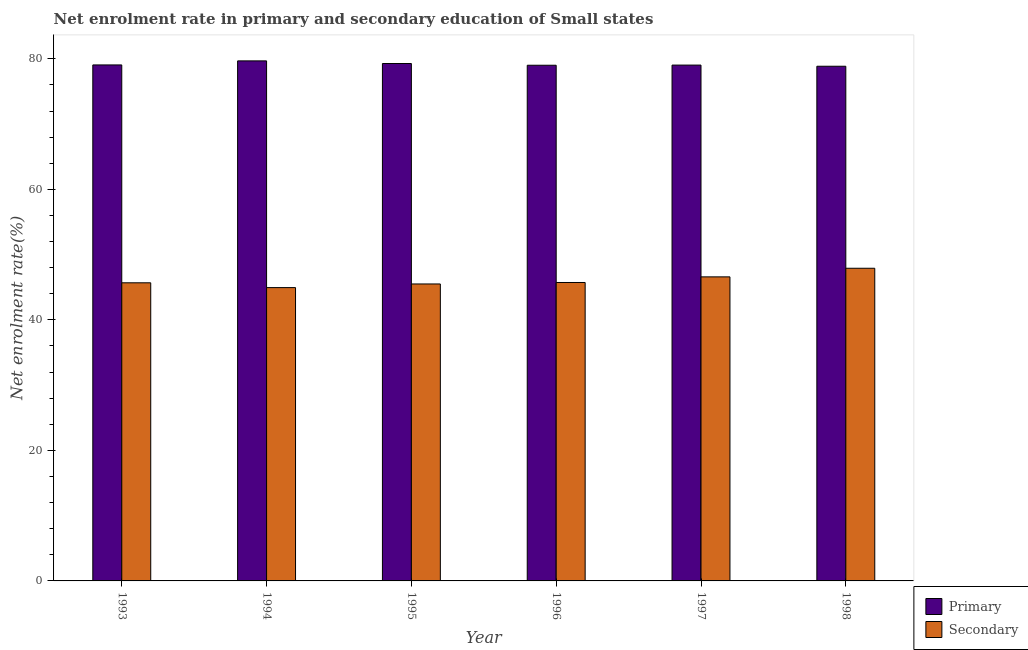Are the number of bars per tick equal to the number of legend labels?
Offer a terse response. Yes. Are the number of bars on each tick of the X-axis equal?
Provide a short and direct response. Yes. What is the label of the 1st group of bars from the left?
Ensure brevity in your answer.  1993. What is the enrollment rate in primary education in 1997?
Your answer should be very brief. 79.04. Across all years, what is the maximum enrollment rate in secondary education?
Your response must be concise. 47.91. Across all years, what is the minimum enrollment rate in primary education?
Offer a very short reply. 78.86. What is the total enrollment rate in secondary education in the graph?
Give a very brief answer. 276.34. What is the difference between the enrollment rate in primary education in 1994 and that in 1998?
Your response must be concise. 0.82. What is the difference between the enrollment rate in primary education in 1997 and the enrollment rate in secondary education in 1996?
Provide a short and direct response. 0.03. What is the average enrollment rate in primary education per year?
Provide a short and direct response. 79.15. In the year 1995, what is the difference between the enrollment rate in secondary education and enrollment rate in primary education?
Ensure brevity in your answer.  0. In how many years, is the enrollment rate in secondary education greater than 24 %?
Make the answer very short. 6. What is the ratio of the enrollment rate in primary education in 1995 to that in 1997?
Give a very brief answer. 1. Is the difference between the enrollment rate in primary education in 1993 and 1997 greater than the difference between the enrollment rate in secondary education in 1993 and 1997?
Offer a terse response. No. What is the difference between the highest and the second highest enrollment rate in primary education?
Give a very brief answer. 0.4. What is the difference between the highest and the lowest enrollment rate in primary education?
Your answer should be compact. 0.82. In how many years, is the enrollment rate in secondary education greater than the average enrollment rate in secondary education taken over all years?
Your answer should be very brief. 2. Is the sum of the enrollment rate in secondary education in 1993 and 1997 greater than the maximum enrollment rate in primary education across all years?
Offer a very short reply. Yes. What does the 2nd bar from the left in 1998 represents?
Keep it short and to the point. Secondary. What does the 1st bar from the right in 1998 represents?
Your response must be concise. Secondary. Are all the bars in the graph horizontal?
Make the answer very short. No. Are the values on the major ticks of Y-axis written in scientific E-notation?
Your answer should be compact. No. Does the graph contain any zero values?
Your response must be concise. No. What is the title of the graph?
Offer a terse response. Net enrolment rate in primary and secondary education of Small states. Does "Technicians" appear as one of the legend labels in the graph?
Offer a terse response. No. What is the label or title of the Y-axis?
Give a very brief answer. Net enrolment rate(%). What is the Net enrolment rate(%) in Primary in 1993?
Your answer should be very brief. 79.06. What is the Net enrolment rate(%) of Secondary in 1993?
Offer a very short reply. 45.68. What is the Net enrolment rate(%) of Primary in 1994?
Make the answer very short. 79.68. What is the Net enrolment rate(%) of Secondary in 1994?
Give a very brief answer. 44.94. What is the Net enrolment rate(%) of Primary in 1995?
Ensure brevity in your answer.  79.28. What is the Net enrolment rate(%) in Secondary in 1995?
Make the answer very short. 45.5. What is the Net enrolment rate(%) of Primary in 1996?
Keep it short and to the point. 79.01. What is the Net enrolment rate(%) of Secondary in 1996?
Your response must be concise. 45.72. What is the Net enrolment rate(%) in Primary in 1997?
Provide a short and direct response. 79.04. What is the Net enrolment rate(%) in Secondary in 1997?
Provide a succinct answer. 46.59. What is the Net enrolment rate(%) in Primary in 1998?
Provide a short and direct response. 78.86. What is the Net enrolment rate(%) of Secondary in 1998?
Make the answer very short. 47.91. Across all years, what is the maximum Net enrolment rate(%) of Primary?
Your response must be concise. 79.68. Across all years, what is the maximum Net enrolment rate(%) of Secondary?
Keep it short and to the point. 47.91. Across all years, what is the minimum Net enrolment rate(%) of Primary?
Make the answer very short. 78.86. Across all years, what is the minimum Net enrolment rate(%) of Secondary?
Provide a short and direct response. 44.94. What is the total Net enrolment rate(%) in Primary in the graph?
Ensure brevity in your answer.  474.93. What is the total Net enrolment rate(%) of Secondary in the graph?
Offer a terse response. 276.34. What is the difference between the Net enrolment rate(%) of Primary in 1993 and that in 1994?
Ensure brevity in your answer.  -0.62. What is the difference between the Net enrolment rate(%) in Secondary in 1993 and that in 1994?
Provide a succinct answer. 0.74. What is the difference between the Net enrolment rate(%) of Primary in 1993 and that in 1995?
Provide a short and direct response. -0.22. What is the difference between the Net enrolment rate(%) in Secondary in 1993 and that in 1995?
Offer a very short reply. 0.18. What is the difference between the Net enrolment rate(%) of Primary in 1993 and that in 1996?
Your answer should be compact. 0.05. What is the difference between the Net enrolment rate(%) in Secondary in 1993 and that in 1996?
Keep it short and to the point. -0.05. What is the difference between the Net enrolment rate(%) of Primary in 1993 and that in 1997?
Keep it short and to the point. 0.02. What is the difference between the Net enrolment rate(%) of Secondary in 1993 and that in 1997?
Your response must be concise. -0.91. What is the difference between the Net enrolment rate(%) in Primary in 1993 and that in 1998?
Ensure brevity in your answer.  0.2. What is the difference between the Net enrolment rate(%) of Secondary in 1993 and that in 1998?
Make the answer very short. -2.23. What is the difference between the Net enrolment rate(%) of Primary in 1994 and that in 1995?
Offer a terse response. 0.4. What is the difference between the Net enrolment rate(%) in Secondary in 1994 and that in 1995?
Provide a short and direct response. -0.56. What is the difference between the Net enrolment rate(%) in Primary in 1994 and that in 1996?
Provide a succinct answer. 0.67. What is the difference between the Net enrolment rate(%) in Secondary in 1994 and that in 1996?
Offer a very short reply. -0.78. What is the difference between the Net enrolment rate(%) in Primary in 1994 and that in 1997?
Your answer should be compact. 0.64. What is the difference between the Net enrolment rate(%) in Secondary in 1994 and that in 1997?
Ensure brevity in your answer.  -1.64. What is the difference between the Net enrolment rate(%) in Primary in 1994 and that in 1998?
Your response must be concise. 0.82. What is the difference between the Net enrolment rate(%) in Secondary in 1994 and that in 1998?
Your answer should be compact. -2.96. What is the difference between the Net enrolment rate(%) of Primary in 1995 and that in 1996?
Your answer should be very brief. 0.27. What is the difference between the Net enrolment rate(%) of Secondary in 1995 and that in 1996?
Give a very brief answer. -0.22. What is the difference between the Net enrolment rate(%) in Primary in 1995 and that in 1997?
Provide a succinct answer. 0.24. What is the difference between the Net enrolment rate(%) of Secondary in 1995 and that in 1997?
Offer a terse response. -1.09. What is the difference between the Net enrolment rate(%) of Primary in 1995 and that in 1998?
Provide a succinct answer. 0.42. What is the difference between the Net enrolment rate(%) of Secondary in 1995 and that in 1998?
Offer a very short reply. -2.41. What is the difference between the Net enrolment rate(%) in Primary in 1996 and that in 1997?
Ensure brevity in your answer.  -0.03. What is the difference between the Net enrolment rate(%) of Secondary in 1996 and that in 1997?
Provide a short and direct response. -0.86. What is the difference between the Net enrolment rate(%) in Primary in 1996 and that in 1998?
Offer a very short reply. 0.15. What is the difference between the Net enrolment rate(%) of Secondary in 1996 and that in 1998?
Your answer should be very brief. -2.18. What is the difference between the Net enrolment rate(%) of Primary in 1997 and that in 1998?
Ensure brevity in your answer.  0.18. What is the difference between the Net enrolment rate(%) of Secondary in 1997 and that in 1998?
Offer a very short reply. -1.32. What is the difference between the Net enrolment rate(%) in Primary in 1993 and the Net enrolment rate(%) in Secondary in 1994?
Offer a terse response. 34.12. What is the difference between the Net enrolment rate(%) in Primary in 1993 and the Net enrolment rate(%) in Secondary in 1995?
Provide a short and direct response. 33.56. What is the difference between the Net enrolment rate(%) in Primary in 1993 and the Net enrolment rate(%) in Secondary in 1996?
Give a very brief answer. 33.34. What is the difference between the Net enrolment rate(%) in Primary in 1993 and the Net enrolment rate(%) in Secondary in 1997?
Your response must be concise. 32.47. What is the difference between the Net enrolment rate(%) in Primary in 1993 and the Net enrolment rate(%) in Secondary in 1998?
Your answer should be compact. 31.15. What is the difference between the Net enrolment rate(%) in Primary in 1994 and the Net enrolment rate(%) in Secondary in 1995?
Provide a short and direct response. 34.18. What is the difference between the Net enrolment rate(%) in Primary in 1994 and the Net enrolment rate(%) in Secondary in 1996?
Keep it short and to the point. 33.96. What is the difference between the Net enrolment rate(%) of Primary in 1994 and the Net enrolment rate(%) of Secondary in 1997?
Keep it short and to the point. 33.09. What is the difference between the Net enrolment rate(%) of Primary in 1994 and the Net enrolment rate(%) of Secondary in 1998?
Keep it short and to the point. 31.78. What is the difference between the Net enrolment rate(%) of Primary in 1995 and the Net enrolment rate(%) of Secondary in 1996?
Ensure brevity in your answer.  33.55. What is the difference between the Net enrolment rate(%) of Primary in 1995 and the Net enrolment rate(%) of Secondary in 1997?
Give a very brief answer. 32.69. What is the difference between the Net enrolment rate(%) in Primary in 1995 and the Net enrolment rate(%) in Secondary in 1998?
Provide a succinct answer. 31.37. What is the difference between the Net enrolment rate(%) in Primary in 1996 and the Net enrolment rate(%) in Secondary in 1997?
Your answer should be very brief. 32.42. What is the difference between the Net enrolment rate(%) of Primary in 1996 and the Net enrolment rate(%) of Secondary in 1998?
Provide a succinct answer. 31.11. What is the difference between the Net enrolment rate(%) of Primary in 1997 and the Net enrolment rate(%) of Secondary in 1998?
Your response must be concise. 31.13. What is the average Net enrolment rate(%) in Primary per year?
Keep it short and to the point. 79.15. What is the average Net enrolment rate(%) of Secondary per year?
Give a very brief answer. 46.06. In the year 1993, what is the difference between the Net enrolment rate(%) in Primary and Net enrolment rate(%) in Secondary?
Give a very brief answer. 33.38. In the year 1994, what is the difference between the Net enrolment rate(%) in Primary and Net enrolment rate(%) in Secondary?
Your answer should be very brief. 34.74. In the year 1995, what is the difference between the Net enrolment rate(%) of Primary and Net enrolment rate(%) of Secondary?
Provide a short and direct response. 33.78. In the year 1996, what is the difference between the Net enrolment rate(%) of Primary and Net enrolment rate(%) of Secondary?
Your answer should be very brief. 33.29. In the year 1997, what is the difference between the Net enrolment rate(%) in Primary and Net enrolment rate(%) in Secondary?
Provide a succinct answer. 32.45. In the year 1998, what is the difference between the Net enrolment rate(%) in Primary and Net enrolment rate(%) in Secondary?
Your answer should be compact. 30.95. What is the ratio of the Net enrolment rate(%) in Secondary in 1993 to that in 1994?
Offer a very short reply. 1.02. What is the ratio of the Net enrolment rate(%) of Secondary in 1993 to that in 1995?
Provide a succinct answer. 1. What is the ratio of the Net enrolment rate(%) of Secondary in 1993 to that in 1996?
Provide a short and direct response. 1. What is the ratio of the Net enrolment rate(%) of Primary in 1993 to that in 1997?
Your answer should be very brief. 1. What is the ratio of the Net enrolment rate(%) of Secondary in 1993 to that in 1997?
Provide a succinct answer. 0.98. What is the ratio of the Net enrolment rate(%) of Primary in 1993 to that in 1998?
Offer a very short reply. 1. What is the ratio of the Net enrolment rate(%) in Secondary in 1993 to that in 1998?
Ensure brevity in your answer.  0.95. What is the ratio of the Net enrolment rate(%) in Primary in 1994 to that in 1996?
Your answer should be very brief. 1.01. What is the ratio of the Net enrolment rate(%) of Secondary in 1994 to that in 1996?
Your answer should be compact. 0.98. What is the ratio of the Net enrolment rate(%) in Primary in 1994 to that in 1997?
Provide a short and direct response. 1.01. What is the ratio of the Net enrolment rate(%) of Secondary in 1994 to that in 1997?
Ensure brevity in your answer.  0.96. What is the ratio of the Net enrolment rate(%) of Primary in 1994 to that in 1998?
Offer a very short reply. 1.01. What is the ratio of the Net enrolment rate(%) in Secondary in 1994 to that in 1998?
Ensure brevity in your answer.  0.94. What is the ratio of the Net enrolment rate(%) in Primary in 1995 to that in 1996?
Ensure brevity in your answer.  1. What is the ratio of the Net enrolment rate(%) in Secondary in 1995 to that in 1997?
Your response must be concise. 0.98. What is the ratio of the Net enrolment rate(%) of Secondary in 1995 to that in 1998?
Your response must be concise. 0.95. What is the ratio of the Net enrolment rate(%) of Secondary in 1996 to that in 1997?
Your answer should be very brief. 0.98. What is the ratio of the Net enrolment rate(%) of Secondary in 1996 to that in 1998?
Offer a very short reply. 0.95. What is the ratio of the Net enrolment rate(%) in Primary in 1997 to that in 1998?
Provide a short and direct response. 1. What is the ratio of the Net enrolment rate(%) in Secondary in 1997 to that in 1998?
Your answer should be compact. 0.97. What is the difference between the highest and the second highest Net enrolment rate(%) of Primary?
Provide a short and direct response. 0.4. What is the difference between the highest and the second highest Net enrolment rate(%) in Secondary?
Keep it short and to the point. 1.32. What is the difference between the highest and the lowest Net enrolment rate(%) in Primary?
Your answer should be very brief. 0.82. What is the difference between the highest and the lowest Net enrolment rate(%) of Secondary?
Provide a short and direct response. 2.96. 